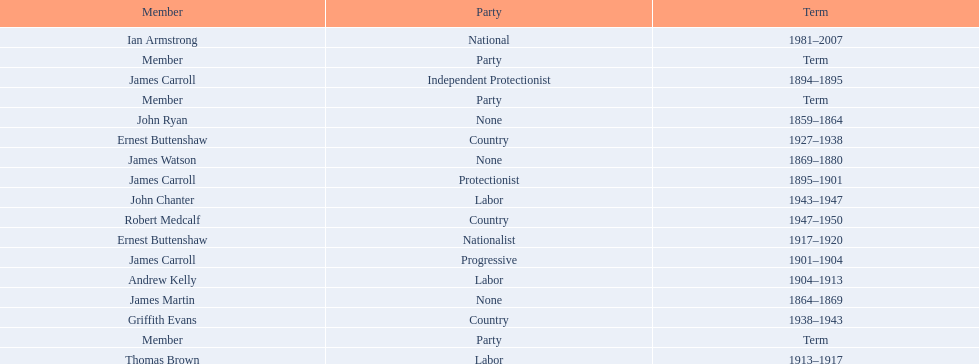How long did ian armstrong serve? 26 years. 